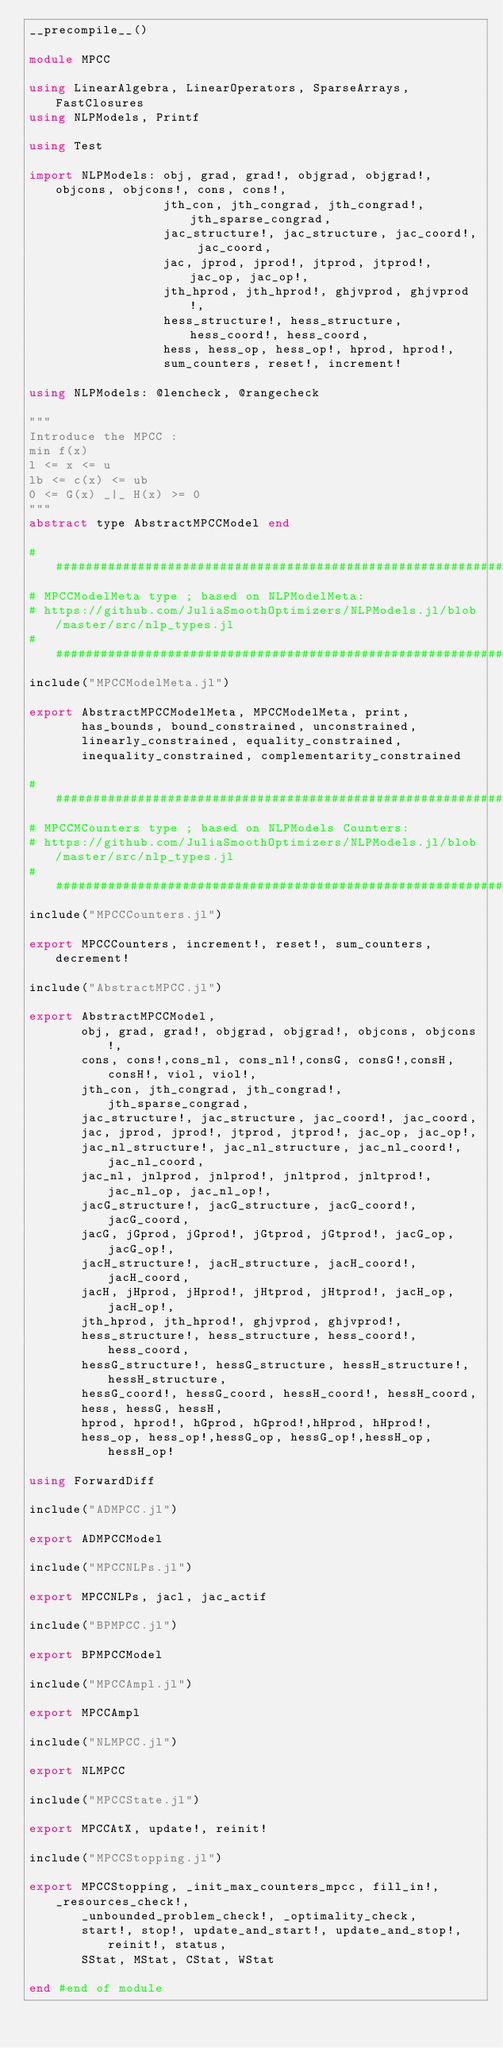Convert code to text. <code><loc_0><loc_0><loc_500><loc_500><_Julia_>__precompile__()

module MPCC

using LinearAlgebra, LinearOperators, SparseArrays, FastClosures
using NLPModels, Printf

using Test

import NLPModels: obj, grad, grad!, objgrad, objgrad!, objcons, objcons!, cons, cons!,
                  jth_con, jth_congrad, jth_congrad!, jth_sparse_congrad,
                  jac_structure!, jac_structure, jac_coord!, jac_coord,
                  jac, jprod, jprod!, jtprod, jtprod!, jac_op, jac_op!,
                  jth_hprod, jth_hprod!, ghjvprod, ghjvprod!,
                  hess_structure!, hess_structure, hess_coord!, hess_coord,
                  hess, hess_op, hess_op!, hprod, hprod!,
                  sum_counters, reset!, increment!

using NLPModels: @lencheck, @rangecheck

"""
Introduce the MPCC :
min f(x)
l <= x <= u
lb <= c(x) <= ub
0 <= G(x) _|_ H(x) >= 0
"""
abstract type AbstractMPCCModel end

#####################################################################################
# MPCCModelMeta type ; based on NLPModelMeta:
# https://github.com/JuliaSmoothOptimizers/NLPModels.jl/blob/master/src/nlp_types.jl
#####################################################################################
include("MPCCModelMeta.jl")

export AbstractMPCCModelMeta, MPCCModelMeta, print,
       has_bounds, bound_constrained, unconstrained,
       linearly_constrained, equality_constrained,
       inequality_constrained, complementarity_constrained

#####################################################################################
# MPCCMCounters type ; based on NLPModels Counters:
# https://github.com/JuliaSmoothOptimizers/NLPModels.jl/blob/master/src/nlp_types.jl
#####################################################################################
include("MPCCCounters.jl")

export MPCCCounters, increment!, reset!, sum_counters, decrement!

include("AbstractMPCC.jl")

export AbstractMPCCModel,
       obj, grad, grad!, objgrad, objgrad!, objcons, objcons!,
       cons, cons!,cons_nl, cons_nl!,consG, consG!,consH, consH!, viol, viol!,
       jth_con, jth_congrad, jth_congrad!, jth_sparse_congrad,
       jac_structure!, jac_structure, jac_coord!, jac_coord,
       jac, jprod, jprod!, jtprod, jtprod!, jac_op, jac_op!,
       jac_nl_structure!, jac_nl_structure, jac_nl_coord!, jac_nl_coord,
       jac_nl, jnlprod, jnlprod!, jnltprod, jnltprod!, jac_nl_op, jac_nl_op!,
       jacG_structure!, jacG_structure, jacG_coord!, jacG_coord,
       jacG, jGprod, jGprod!, jGtprod, jGtprod!, jacG_op, jacG_op!,
       jacH_structure!, jacH_structure, jacH_coord!, jacH_coord,
       jacH, jHprod, jHprod!, jHtprod, jHtprod!, jacH_op, jacH_op!,
       jth_hprod, jth_hprod!, ghjvprod, ghjvprod!,
       hess_structure!, hess_structure, hess_coord!, hess_coord,
       hessG_structure!, hessG_structure, hessH_structure!, hessH_structure,
       hessG_coord!, hessG_coord, hessH_coord!, hessH_coord,
       hess, hessG, hessH,
       hprod, hprod!, hGprod, hGprod!,hHprod, hHprod!,
       hess_op, hess_op!,hessG_op, hessG_op!,hessH_op, hessH_op!

using ForwardDiff

include("ADMPCC.jl")

export ADMPCCModel

include("MPCCNLPs.jl")

export MPCCNLPs, jacl, jac_actif

include("BPMPCC.jl")

export BPMPCCModel

include("MPCCAmpl.jl")

export MPCCAmpl

include("NLMPCC.jl")

export NLMPCC

include("MPCCState.jl")

export MPCCAtX, update!, reinit!

include("MPCCStopping.jl")

export MPCCStopping, _init_max_counters_mpcc, fill_in!, _resources_check!,
       _unbounded_problem_check!, _optimality_check,
       start!, stop!, update_and_start!, update_and_stop!, reinit!, status,
       SStat, MStat, CStat, WStat

end #end of module
</code> 